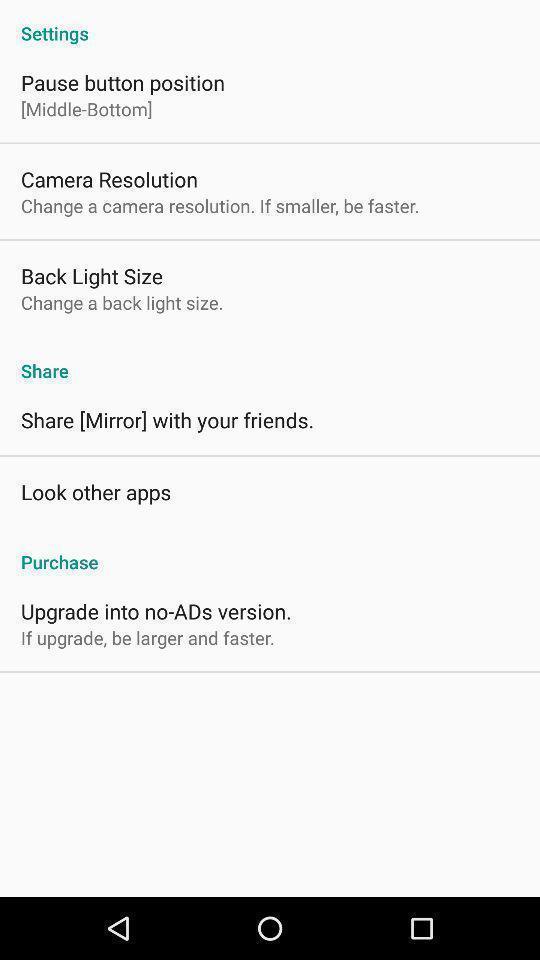What details can you identify in this image? Window displaying settings of camera. 